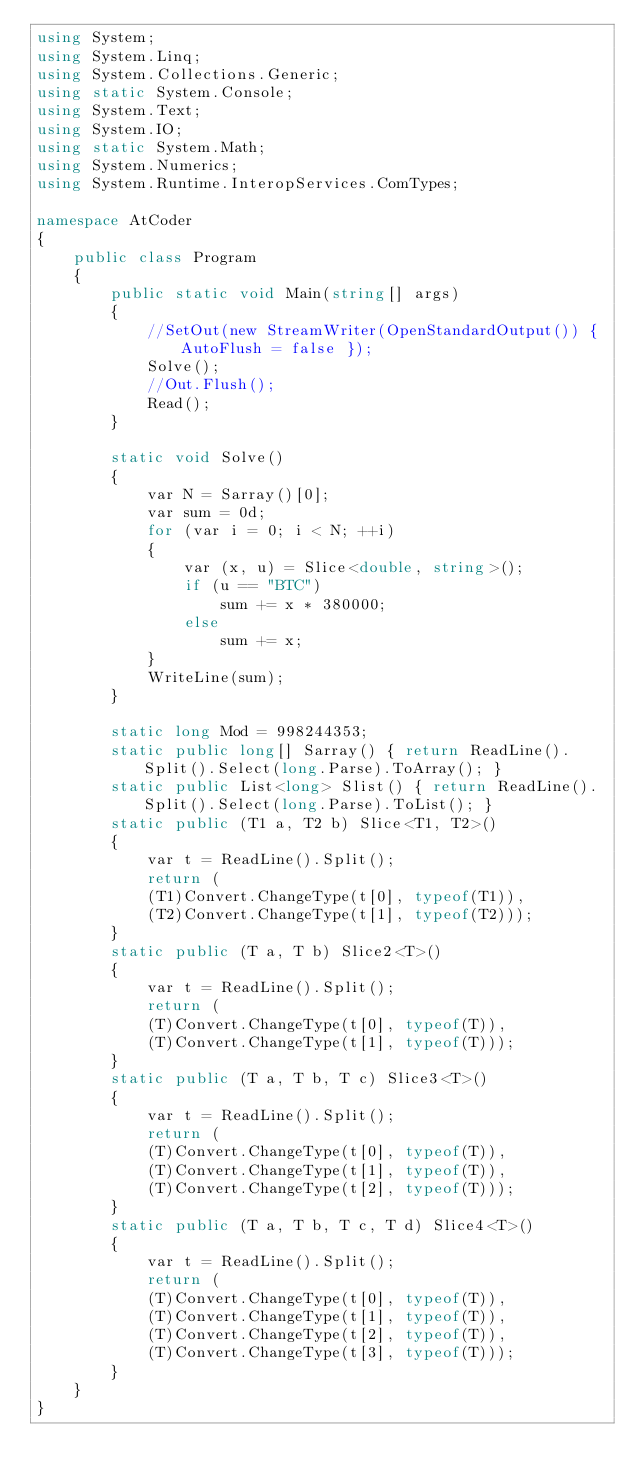Convert code to text. <code><loc_0><loc_0><loc_500><loc_500><_C#_>using System;
using System.Linq;
using System.Collections.Generic;
using static System.Console;
using System.Text;
using System.IO;
using static System.Math;
using System.Numerics;
using System.Runtime.InteropServices.ComTypes;

namespace AtCoder
{
    public class Program
    {
        public static void Main(string[] args)
        {
            //SetOut(new StreamWriter(OpenStandardOutput()) { AutoFlush = false });
            Solve();
            //Out.Flush();
            Read();
        }

        static void Solve()
        {
            var N = Sarray()[0];
            var sum = 0d;
            for (var i = 0; i < N; ++i)
            {
                var (x, u) = Slice<double, string>();
                if (u == "BTC")
                    sum += x * 380000;
                else
                    sum += x;
            }
            WriteLine(sum);
        }

        static long Mod = 998244353;
        static public long[] Sarray() { return ReadLine().Split().Select(long.Parse).ToArray(); }
        static public List<long> Slist() { return ReadLine().Split().Select(long.Parse).ToList(); }
        static public (T1 a, T2 b) Slice<T1, T2>()
        {
            var t = ReadLine().Split();
            return (
            (T1)Convert.ChangeType(t[0], typeof(T1)),
            (T2)Convert.ChangeType(t[1], typeof(T2)));
        }
        static public (T a, T b) Slice2<T>()
        {
            var t = ReadLine().Split();
            return (
            (T)Convert.ChangeType(t[0], typeof(T)),
            (T)Convert.ChangeType(t[1], typeof(T)));
        }
        static public (T a, T b, T c) Slice3<T>()
        {
            var t = ReadLine().Split();
            return (
            (T)Convert.ChangeType(t[0], typeof(T)),
            (T)Convert.ChangeType(t[1], typeof(T)),
            (T)Convert.ChangeType(t[2], typeof(T)));
        }
        static public (T a, T b, T c, T d) Slice4<T>()
        {
            var t = ReadLine().Split();
            return (
            (T)Convert.ChangeType(t[0], typeof(T)),
            (T)Convert.ChangeType(t[1], typeof(T)),
            (T)Convert.ChangeType(t[2], typeof(T)),
            (T)Convert.ChangeType(t[3], typeof(T)));
        }
    }
}</code> 